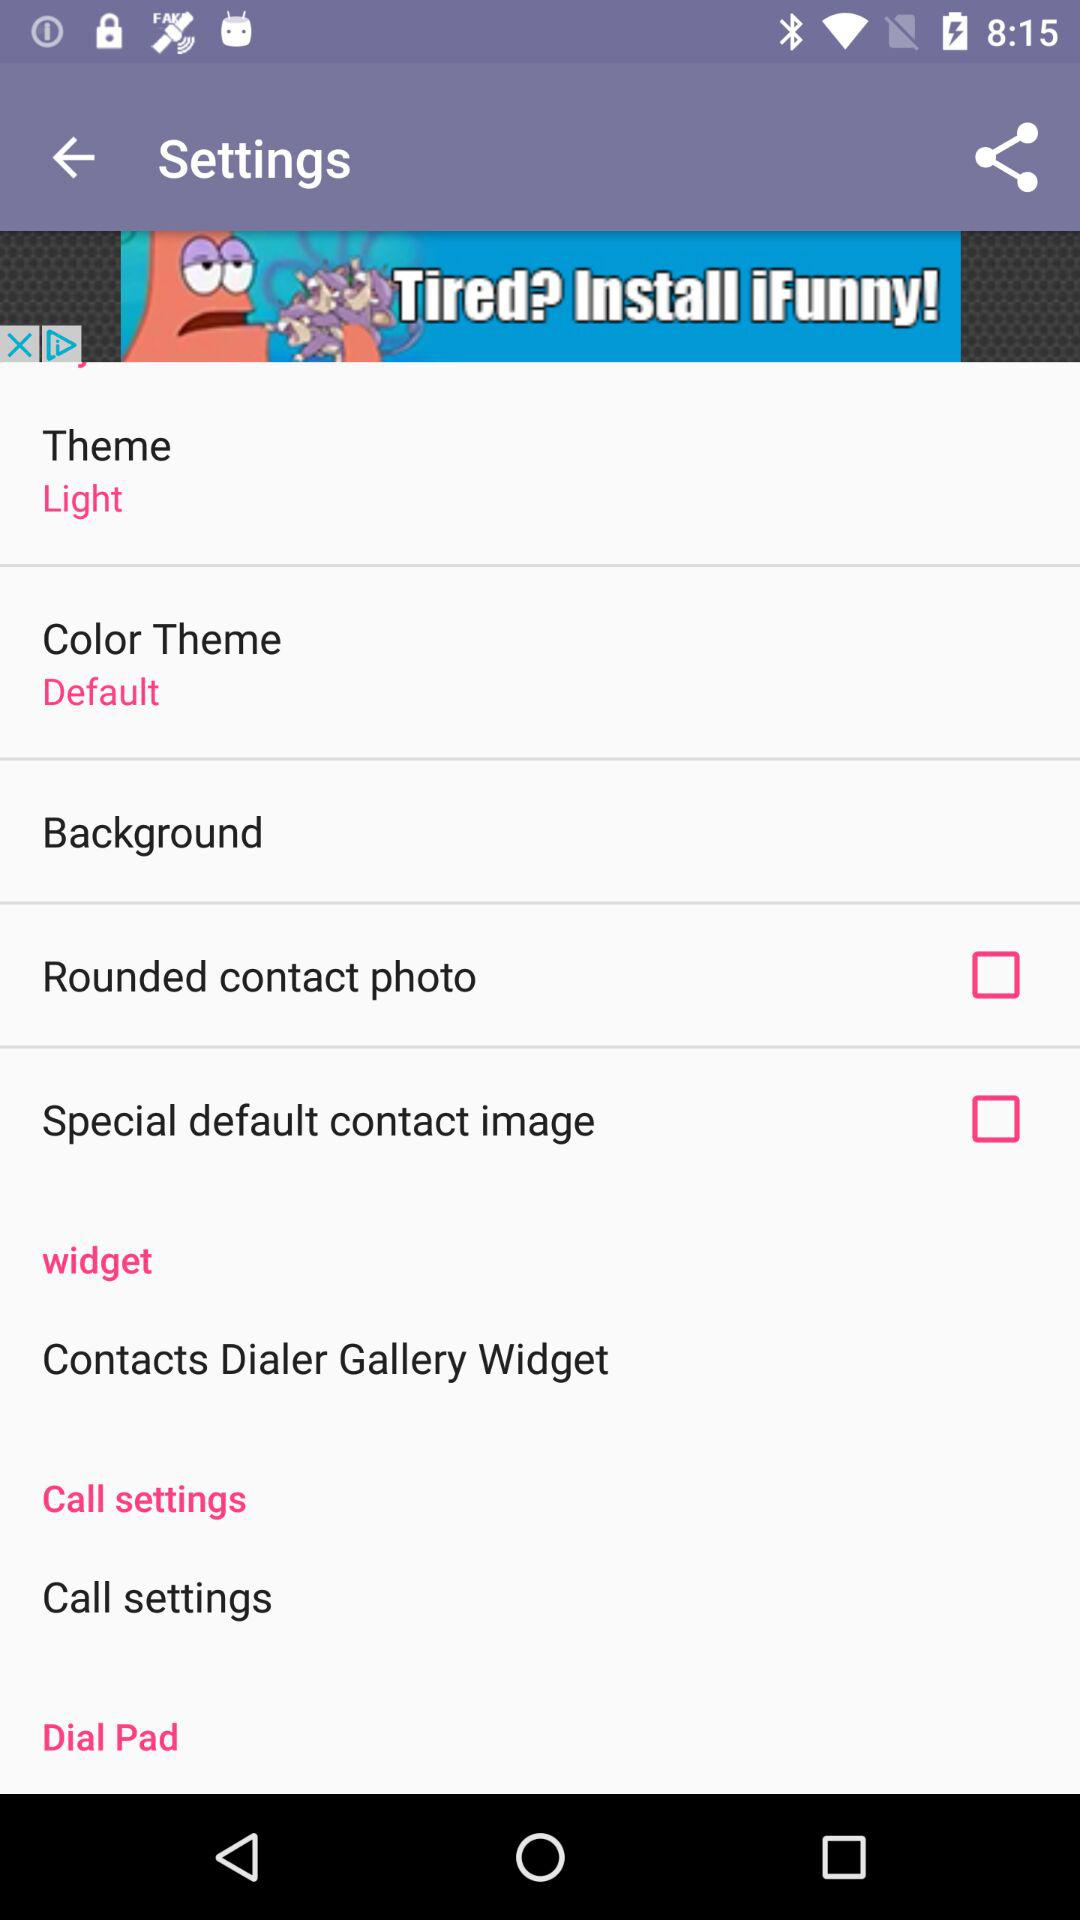What is the setting for the theme? The setting is "Light". 